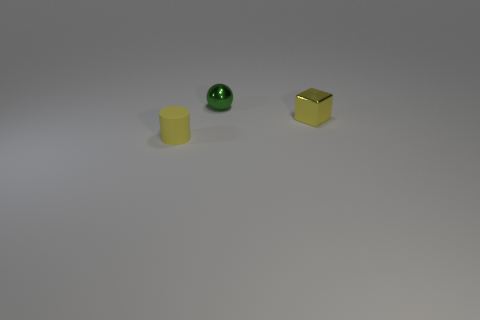What material is the tiny green ball?
Your answer should be very brief. Metal. What shape is the tiny yellow thing to the right of the thing that is behind the yellow metallic object?
Provide a succinct answer. Cube. There is a tiny yellow object that is to the left of the tiny sphere; what shape is it?
Ensure brevity in your answer.  Cylinder. What number of shiny objects have the same color as the tiny rubber thing?
Provide a short and direct response. 1. What is the color of the tiny cube?
Your answer should be very brief. Yellow. There is a yellow thing in front of the yellow metal object; what number of tiny yellow metal blocks are in front of it?
Offer a terse response. 0. There is a yellow metal block; is it the same size as the cylinder that is in front of the tiny green sphere?
Your answer should be compact. Yes. Do the rubber thing and the yellow metallic cube have the same size?
Offer a terse response. Yes. Are there any cyan cubes that have the same size as the yellow cylinder?
Provide a succinct answer. No. There is a small yellow object that is to the left of the tiny yellow cube; what material is it?
Make the answer very short. Rubber. 